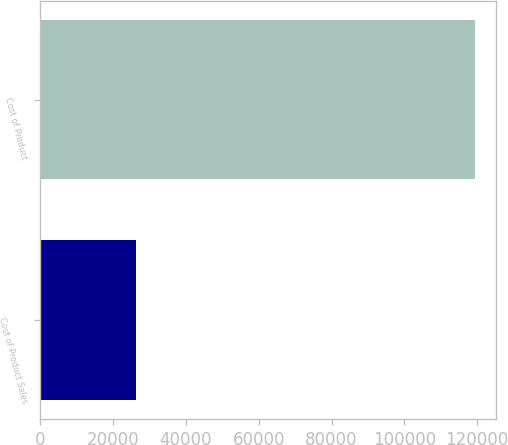<chart> <loc_0><loc_0><loc_500><loc_500><bar_chart><fcel>Cost of Product Sales<fcel>Cost of Product<nl><fcel>26263.7<fcel>119285<nl></chart> 